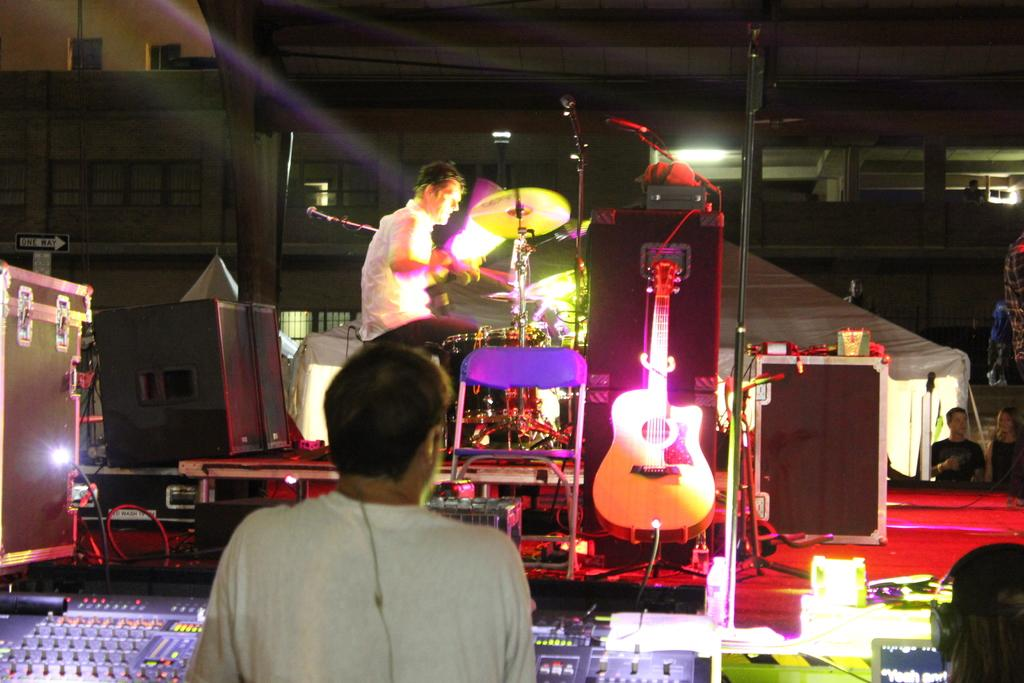What is the person in the image doing? The person is playing a musical instrument. What type of musical instrument is the person playing? The person is playing a guitar. Is there any furniture in the image? Yes, there is a chair in the image. What is the position of the person in the image? The person is standing. How many girls are on stage with the laborer in the image? There is no laborer, girls, or stage present in the image. 